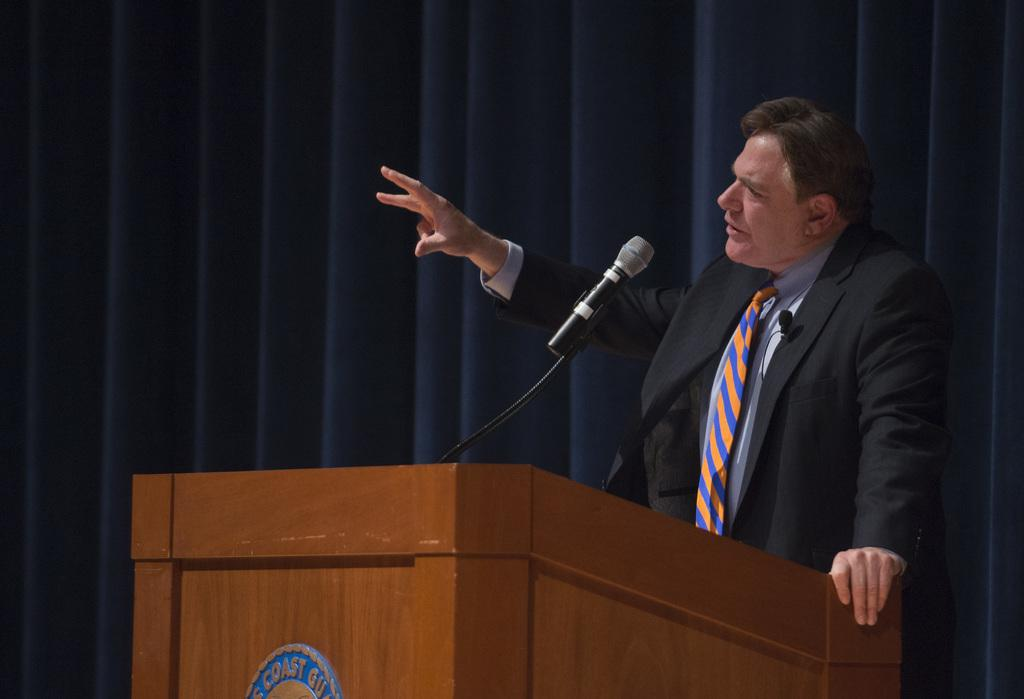What is the person in the image doing? The person is standing at a desk in the image. What object is on the desk in the image? There is a microphone (mic) on the desk. What can be seen in the background of the image? There is a curtain in the background of the image. What type of crime is being committed in the image? There is no indication of any crime being committed in the image. The person is simply standing at a desk with a microphone. 